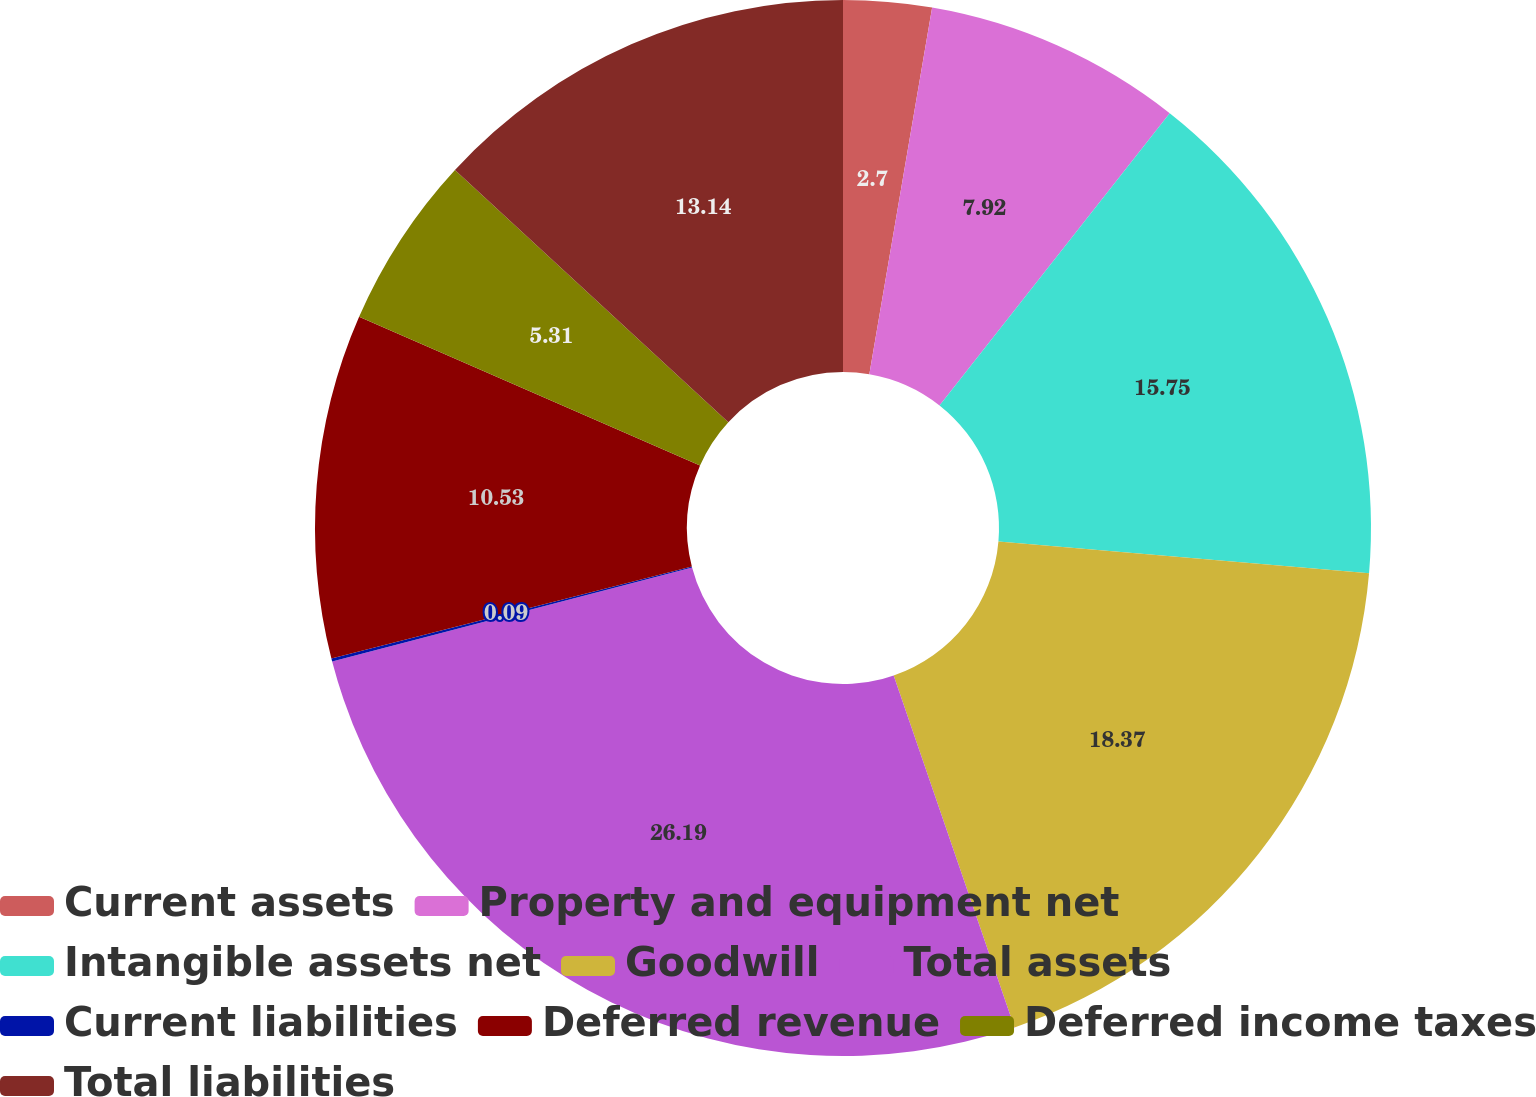Convert chart to OTSL. <chart><loc_0><loc_0><loc_500><loc_500><pie_chart><fcel>Current assets<fcel>Property and equipment net<fcel>Intangible assets net<fcel>Goodwill<fcel>Total assets<fcel>Current liabilities<fcel>Deferred revenue<fcel>Deferred income taxes<fcel>Total liabilities<nl><fcel>2.7%<fcel>7.92%<fcel>15.75%<fcel>18.37%<fcel>26.2%<fcel>0.09%<fcel>10.53%<fcel>5.31%<fcel>13.14%<nl></chart> 